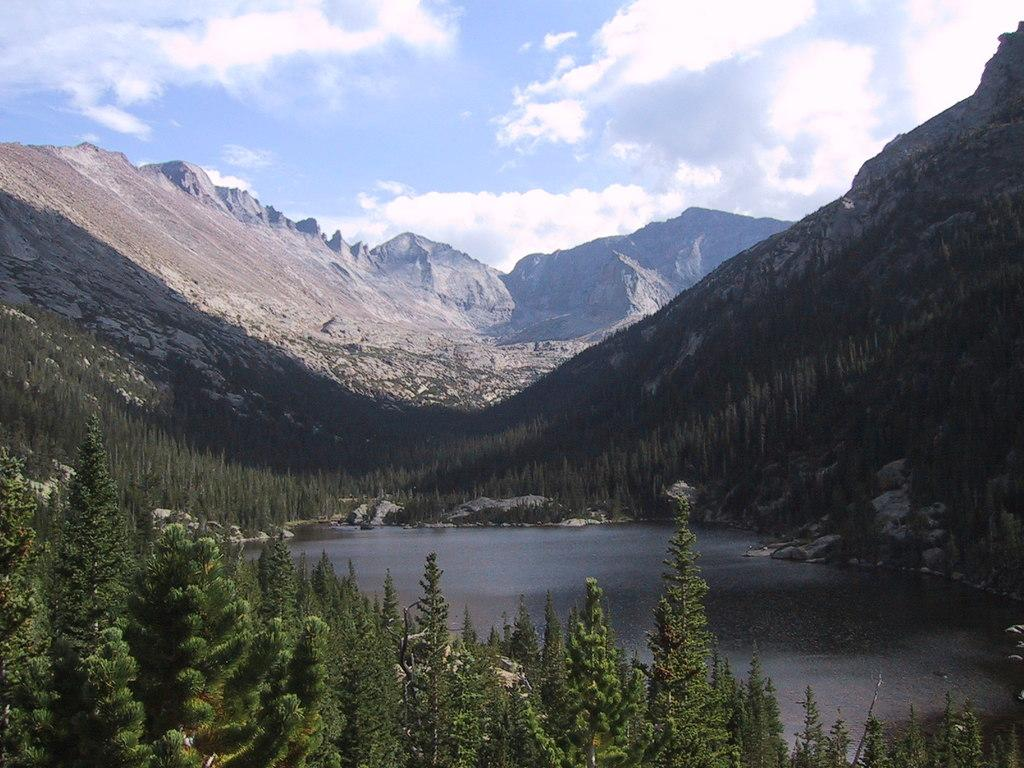What type of water body can be seen in the image? There is a small lake in the image. What other natural elements are present in the image? There are plants, trees, and hills visible in the image. What can be seen in the background of the image? The sky is visible in the background of the image, and clouds are present in the sky. Where is the market located in the image? There is no market present in the image. What type of pen is used to draw the plants in the image? The image is a photograph, not a drawing, so there is no pen used to create it. 